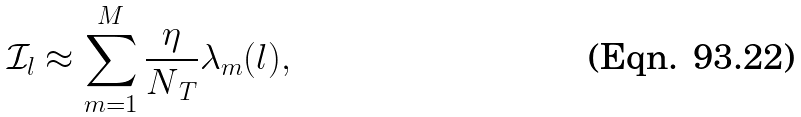<formula> <loc_0><loc_0><loc_500><loc_500>\mathcal { I } _ { l } \approx \sum _ { m = 1 } ^ { M } \frac { \eta } { N _ { \, T } } \lambda _ { m } ( l ) ,</formula> 